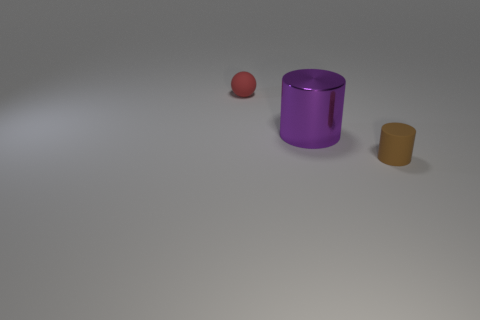Are the red thing and the large purple cylinder made of the same material? It is not possible to determine if the red object and the large purple cylinder are made from the same material just by looking at the image. They exhibit different colors and potentially different textures. To accurately ascertain material composition, one would need additional information such as physical examination or details from the creator. 